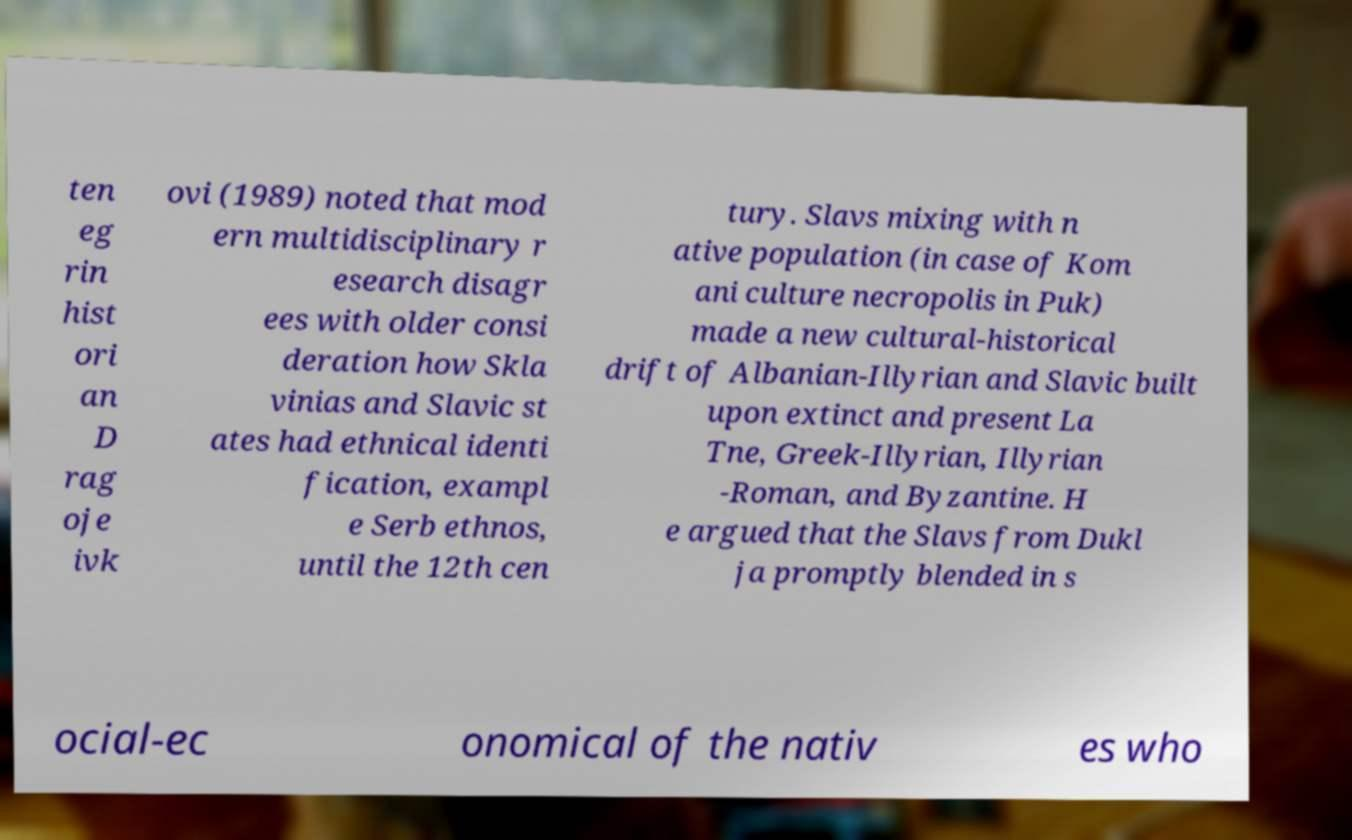Could you extract and type out the text from this image? ten eg rin hist ori an D rag oje ivk ovi (1989) noted that mod ern multidisciplinary r esearch disagr ees with older consi deration how Skla vinias and Slavic st ates had ethnical identi fication, exampl e Serb ethnos, until the 12th cen tury. Slavs mixing with n ative population (in case of Kom ani culture necropolis in Puk) made a new cultural-historical drift of Albanian-Illyrian and Slavic built upon extinct and present La Tne, Greek-Illyrian, Illyrian -Roman, and Byzantine. H e argued that the Slavs from Dukl ja promptly blended in s ocial-ec onomical of the nativ es who 